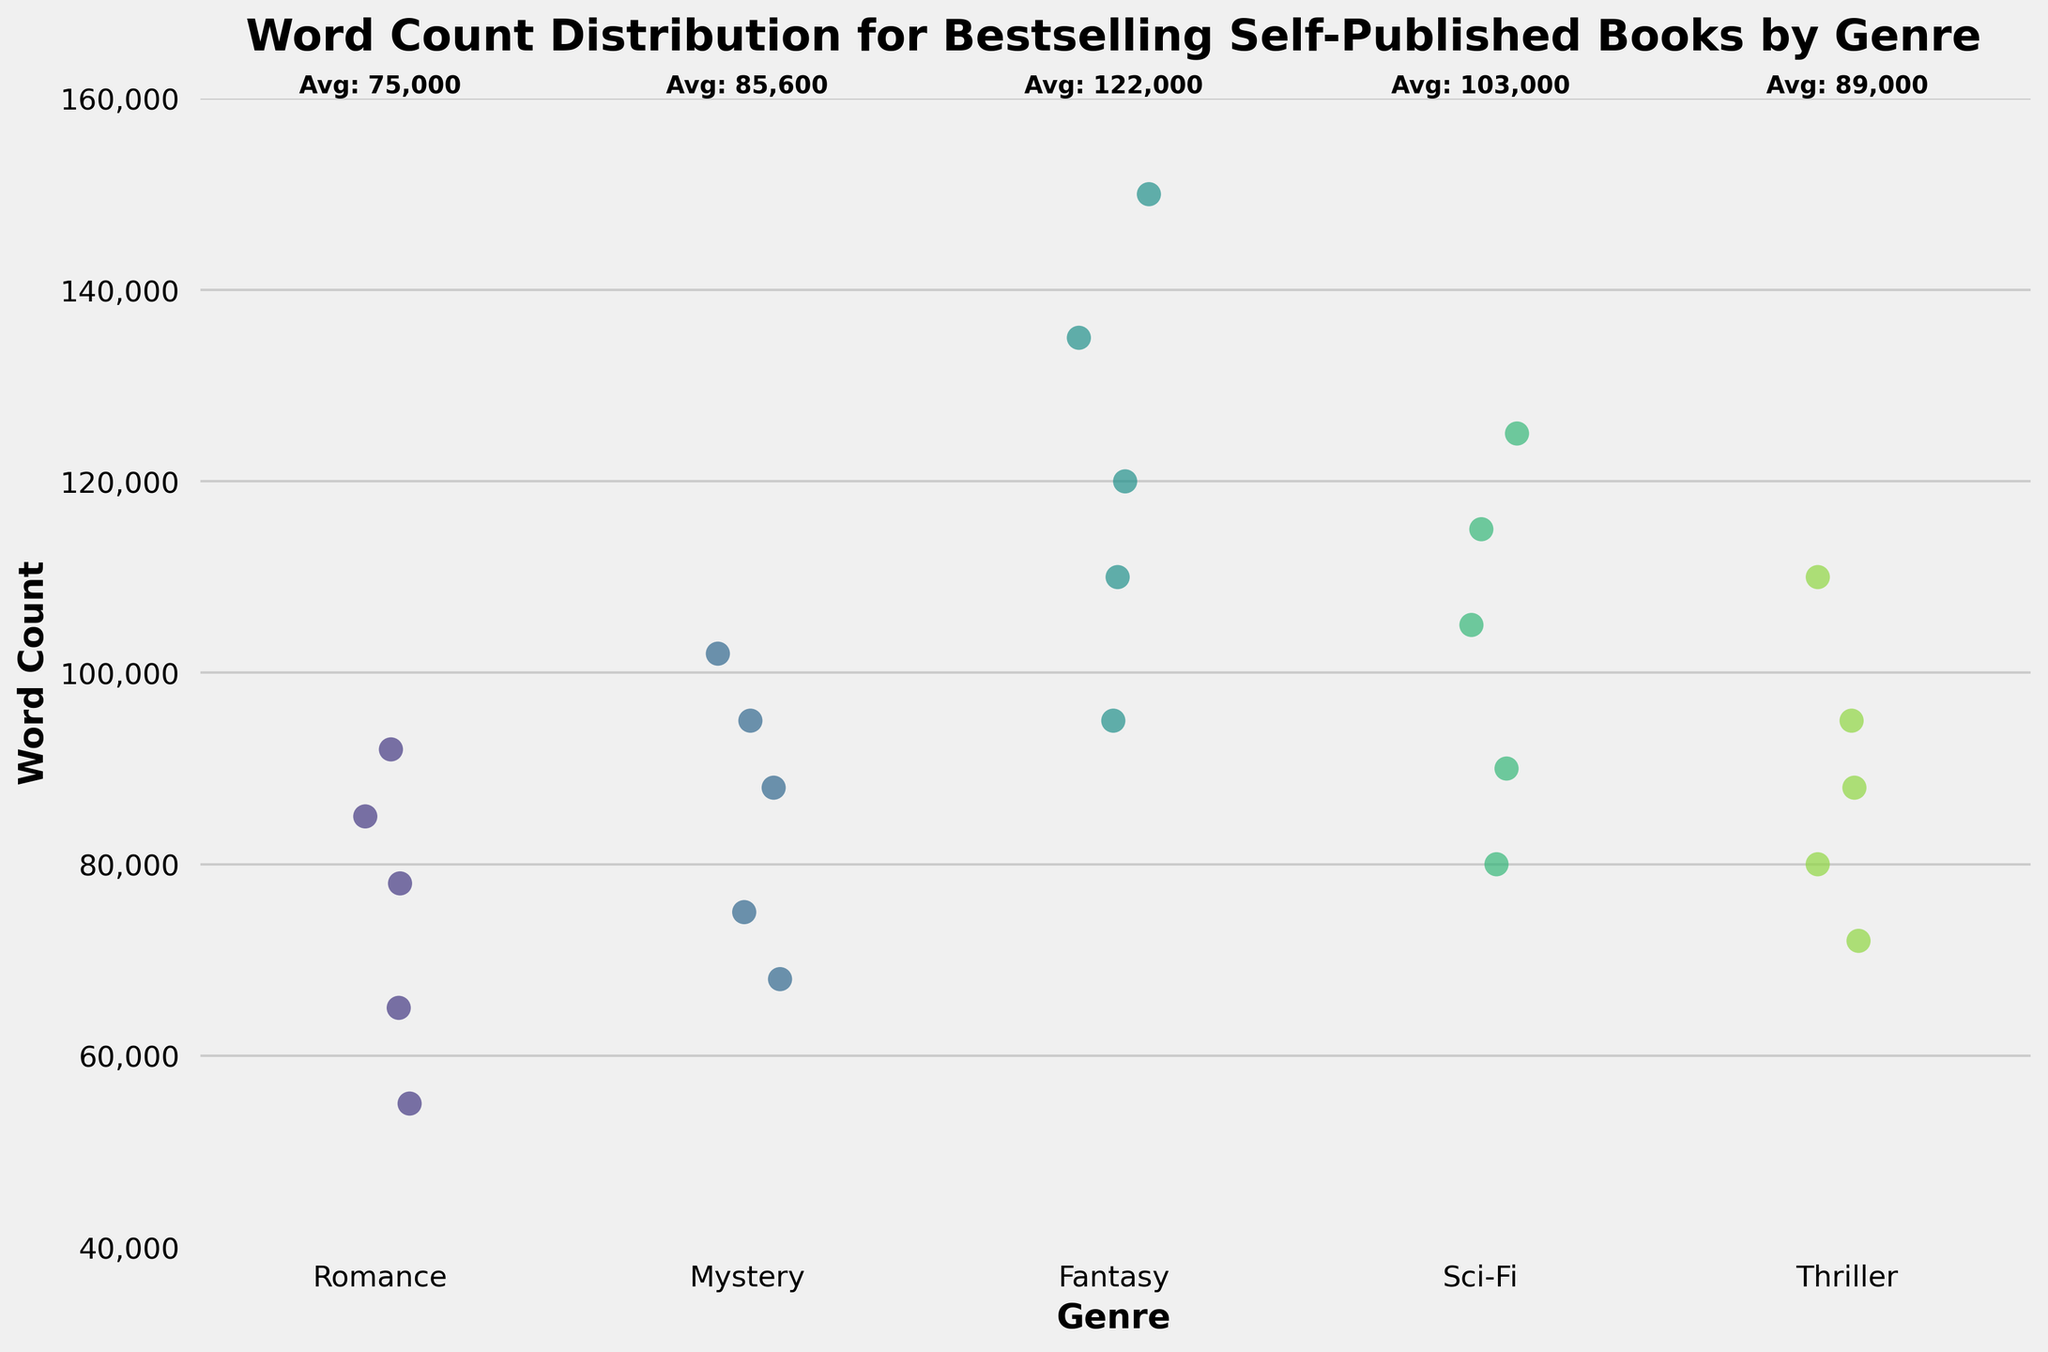What is the title of the figure? The title of a figure is generally the large text located at the top, which in this case reads 'Word Count Distribution for Bestselling Self-Published Books by Genre'.
Answer: Word Count Distribution for Bestselling Self-Published Books by Genre Which genre has the highest average word count? Look for the textual annotation above each genre's data points in the figure. The genre with the highest average word count is labeled 'Fantasy' with an average word count provided above it.
Answer: Fantasy What is the range of word counts for the Sci-Fi genre? By examining the spread of data points within the Sci-Fi category along the y-axis, we identify the lowest and highest word count values, which are approximately 80,000 and 125,000 words respectively.
Answer: 80,000 to 125,000 Which genre has the widest spread (range) of word counts? The range is determined by the difference between the highest and lowest data points for each genre. For 'Fantasy', the values span from about 95,000 to 150,000 words, making it the genre with the widest spread.
Answer: Fantasy Are there any genres that have overlapping word count ranges? If so, which ones? To determine overlap, one must see if there are intersecting word count values between genres. Romance overlaps with Mystery and Thriller.
Answer: Romance with Mystery and Thriller What genres have a minimum word count of around 55,000 words? Check the lower extremities of the data points for each genre. Here, only the Romance genre has a data point around 55,000 words.
Answer: Romance Which genre(s) have the least number of data points (books)? Count the number of individual data points scattered for each genre in the strip plot. Each genre has 5 data points, so they are equal.
Answer: All genres have an equal count Is the word count distribution for the Romance genre higher or lower compared to the Mystery genre? Compare the spread of data points along the vertical axis for both genres. The Mystery genre has data points that generally lie higher on the y-axis compared to the Romance genre.
Answer: Lower What is the average word count for the Thriller genre as given in the figure annotations? Check the textual annotations above the Thriller data points that show 'Avg: ...'. The average word count for Thriller is given directly as a number.
Answer: 89,600 